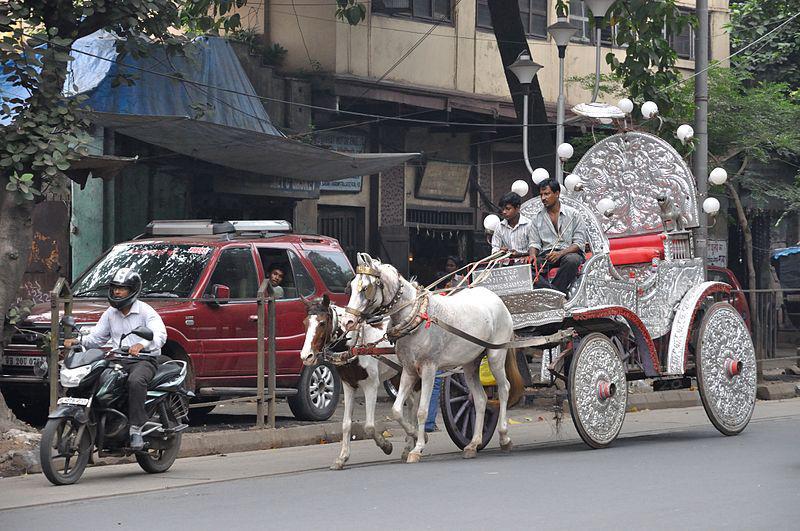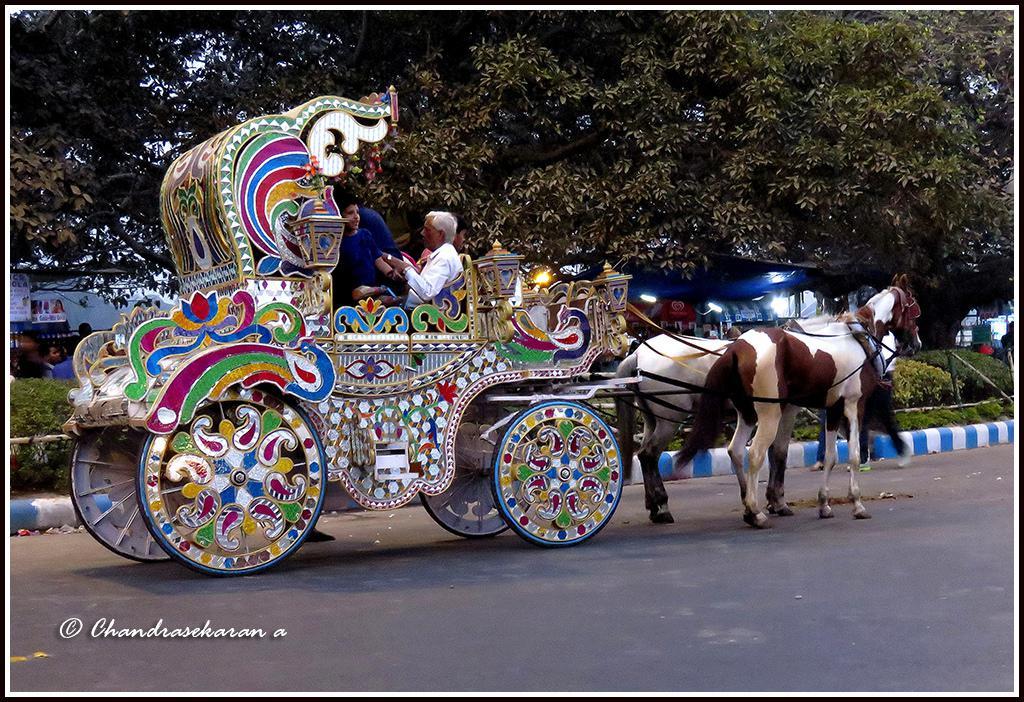The first image is the image on the left, the second image is the image on the right. For the images displayed, is the sentence "An image shows a leftward-headed wagon with ornate white wheels, pulled by at least one white horse." factually correct? Answer yes or no. Yes. 